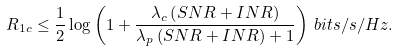<formula> <loc_0><loc_0><loc_500><loc_500>R _ { 1 c } \leq \frac { 1 } { 2 } \log \left ( 1 + \frac { \lambda _ { c } \left ( S N R + I N R \right ) } { \lambda _ { p } \left ( S N R + I N R \right ) + 1 } \right ) \, b i t s / s / H z .</formula> 